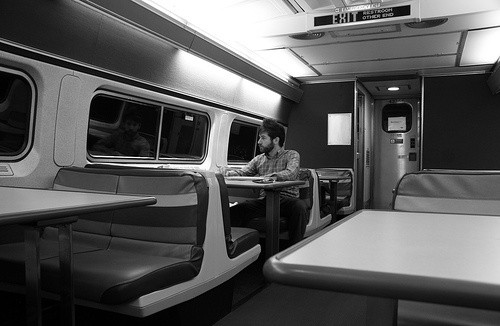Describe the objects in this image and their specific colors. I can see dining table in black, darkgray, lightgray, and gray tones, bench in black, gray, and lightgray tones, dining table in black, darkgray, gray, and lightgray tones, people in black, gray, darkgray, and lightgray tones, and bench in black, gray, darkgray, and lightgray tones in this image. 